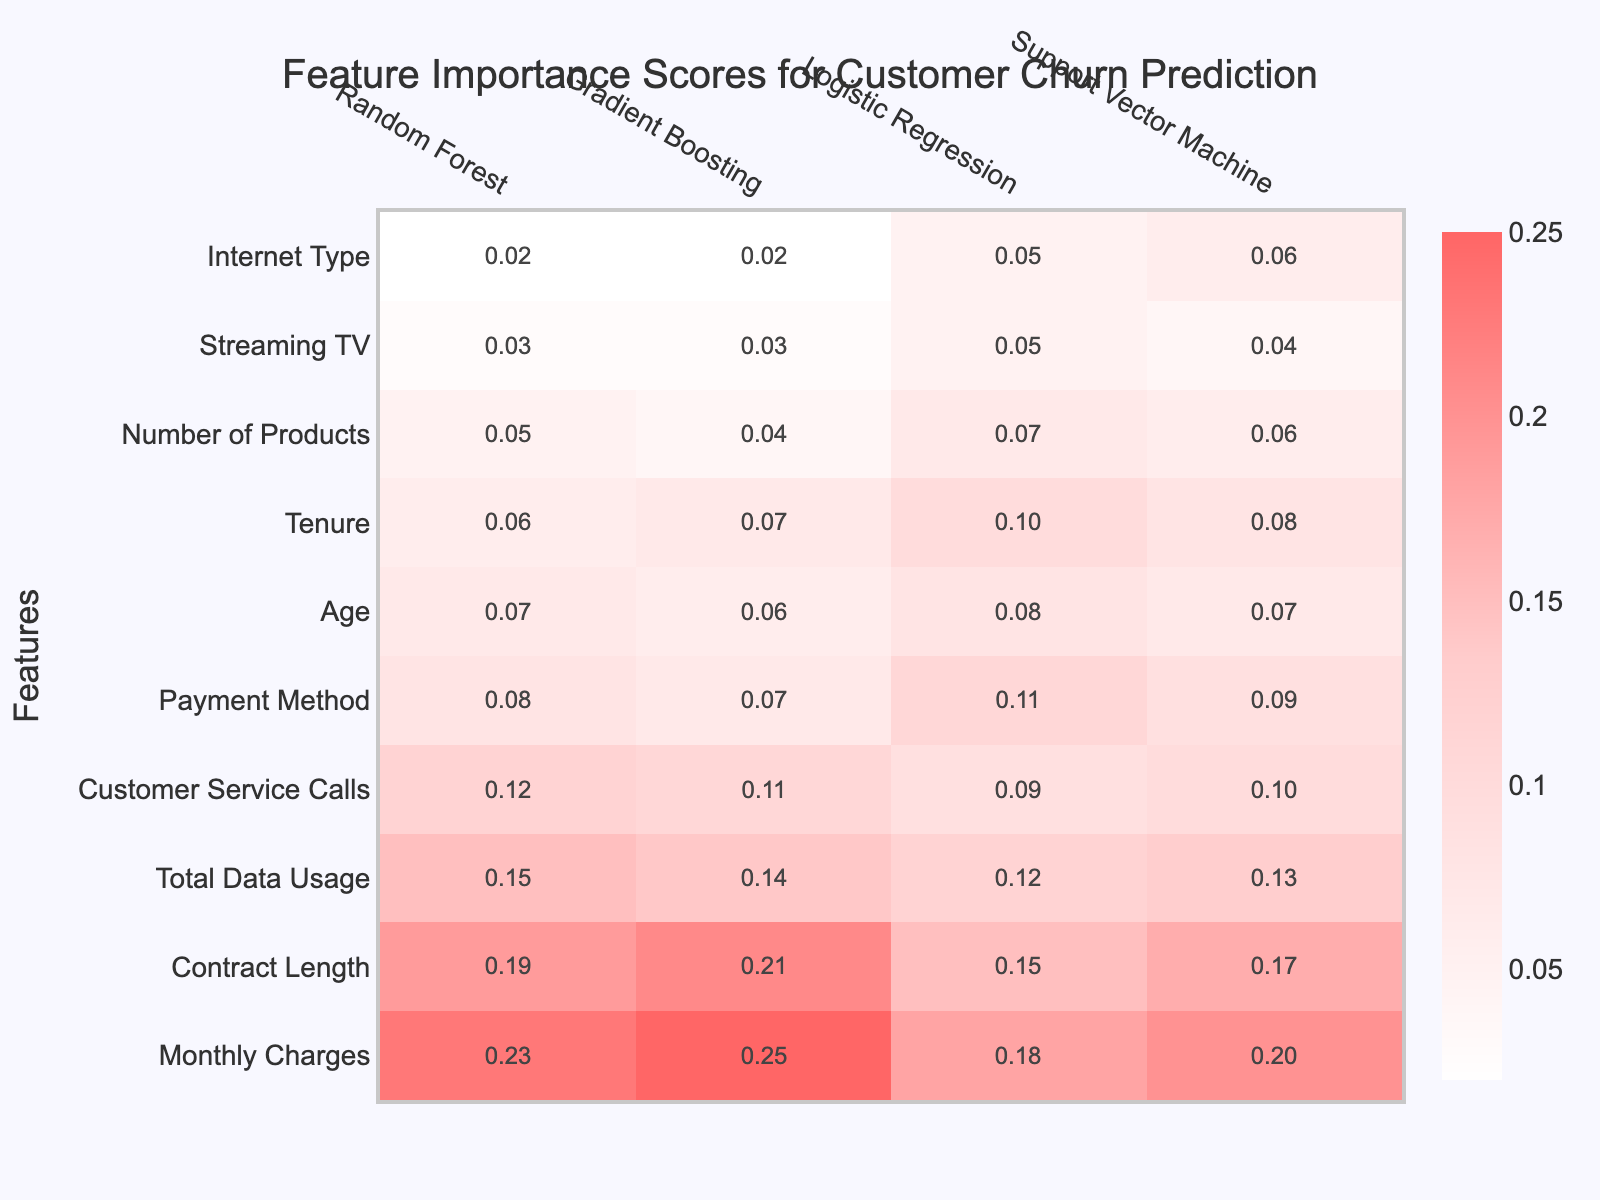What is the feature with the highest importance score in the Random Forest model? In the Random Forest model, the importance scores for each feature are listed. The scores indicate the contribution of each feature to the model's predictions. Scanning the column for Random Forest, we find that "Monthly Charges" has the highest score of 0.23.
Answer: Monthly Charges Which feature has the lowest importance score across all models? By examining the scores for each feature across all model columns, we find that "Streaming TV" has the lowest score of 0.03 in both Random Forest and Gradient Boosting models. It is also 0.05 in Logistic Regression and 0.04 in Support Vector Machine. Thus, it has the lowest maximum score across all models.
Answer: Streaming TV What is the average importance score of "Contract Length" across all models? To find the average, we sum the importance scores of "Contract Length" from each model: 0.19 (Random Forest) + 0.21 (Gradient Boosting) + 0.15 (Logistic Regression) + 0.17 (Support Vector Machine) = 0.72. Then we divide by the number of models (4), giving us 0.72 / 4 = 0.18.
Answer: 0.18 Is "Customer Service Calls" more important than "Total Data Usage" for the Gradient Boosting model? We compare the scores for both features under Gradient Boosting. "Customer Service Calls" has a score of 0.11, while "Total Data Usage" has a score of 0.14. Since 0.14 is greater than 0.11, we conclude that "Customer Service Calls" is indeed less important than "Total Data Usage" in the Gradient Boosting model.
Answer: No What is the total importance score for "Age" and "Tenure" in Support Vector Machine? We first find the scores for "Age" and "Tenure" under the Support Vector Machine column. "Age" scores 0.07 and "Tenure" scores 0.08. Adding these two gives us a total score of 0.07 + 0.08 = 0.15.
Answer: 0.15 Which model gives the feature "Payment Method" the highest importance score? Looking at the scores for "Payment Method" across all models, we see it scores 0.08 in Random Forest, 0.07 in Gradient Boosting, 0.11 in Logistic Regression, and 0.09 in Support Vector Machine. The highest score is 0.11 from the Logistic Regression model.
Answer: Logistic Regression If the feature importance scores were normalized to a 0-1 scale, which features would retain their ranking from Random Forest? To retain their ranking, we check the relative differences between scores. The order of importance scores for Random Forest is: "Monthly Charges" (0.23) > "Contract Length" (0.19) > "Total Data Usage" (0.15) > "Customer Service Calls" (0.12) > "Payment Method" (0.08) > "Age" (0.07) > "Tenure" (0.06) > "Number of Products" (0.05) > "Streaming TV" (0.03) > "Internet Type" (0.02). Given the distinct differences, they are likely to retain their ranking even after normalization.
Answer: Yes What is the score difference between "Contract Length" and "Total Data Usage" in Logistic Regression? We take the scores for "Contract Length" which is 0.15, and "Total Data Usage" which is 0.12 from the Logistic Regression model. The difference is calculated as 0.15 - 0.12 = 0.03.
Answer: 0.03 In which model is "Age" least important? Scanning the importance scores for "Age," we note it has values of 0.07 (Random Forest), 0.06 (Gradient Boosting), 0.08 (Logistic Regression), and 0.07 (Support Vector Machine). The lowest score is 0.06, which corresponds to the Gradient Boosting model.
Answer: Gradient Boosting How do the importance scores of "Number of Products" compare between Random Forest and Logistic Regression? The scores for "Number of Products" are 0.05 in Random Forest and 0.07 in Logistic Regression. Since 0.07 is greater than 0.05, the importance of "Number of Products" is higher in Logistic Regression.
Answer: Higher in Logistic Regression 